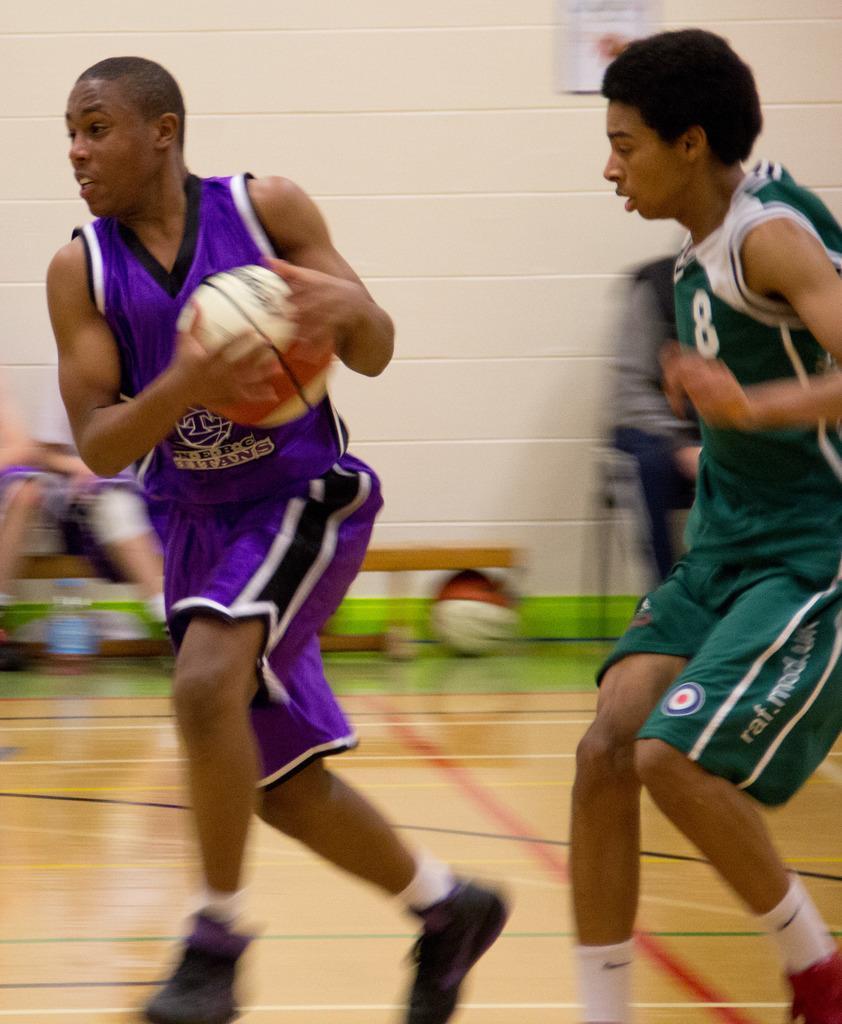Can you describe this image briefly? On the left side, we see a man in the violet T-shirt is holding a basketball. He is running. Behind him, we see a man in the green T-shirt is running behind him. They might be playing the basketball. Behind him, we see two people are sitting on the bench. We see a water bottle and a basketball under the bench. In the background, we see a white wall on which a photo frame is placed. This picture might be clicked in the basketball court. 